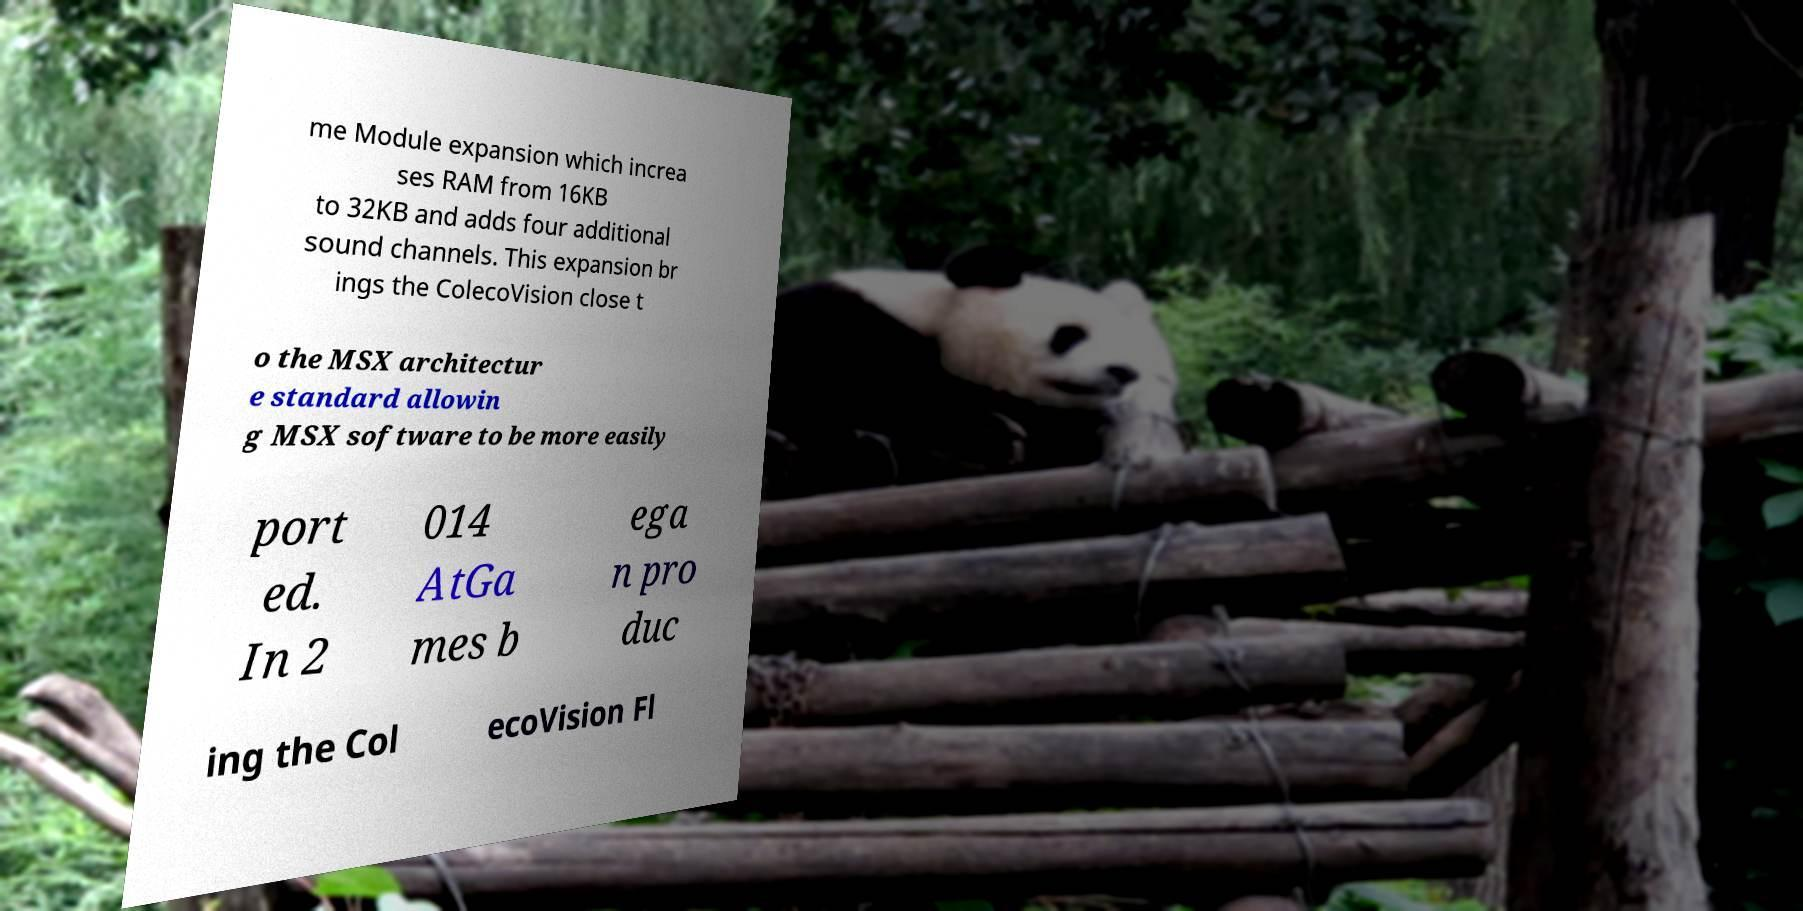For documentation purposes, I need the text within this image transcribed. Could you provide that? me Module expansion which increa ses RAM from 16KB to 32KB and adds four additional sound channels. This expansion br ings the ColecoVision close t o the MSX architectur e standard allowin g MSX software to be more easily port ed. In 2 014 AtGa mes b ega n pro duc ing the Col ecoVision Fl 